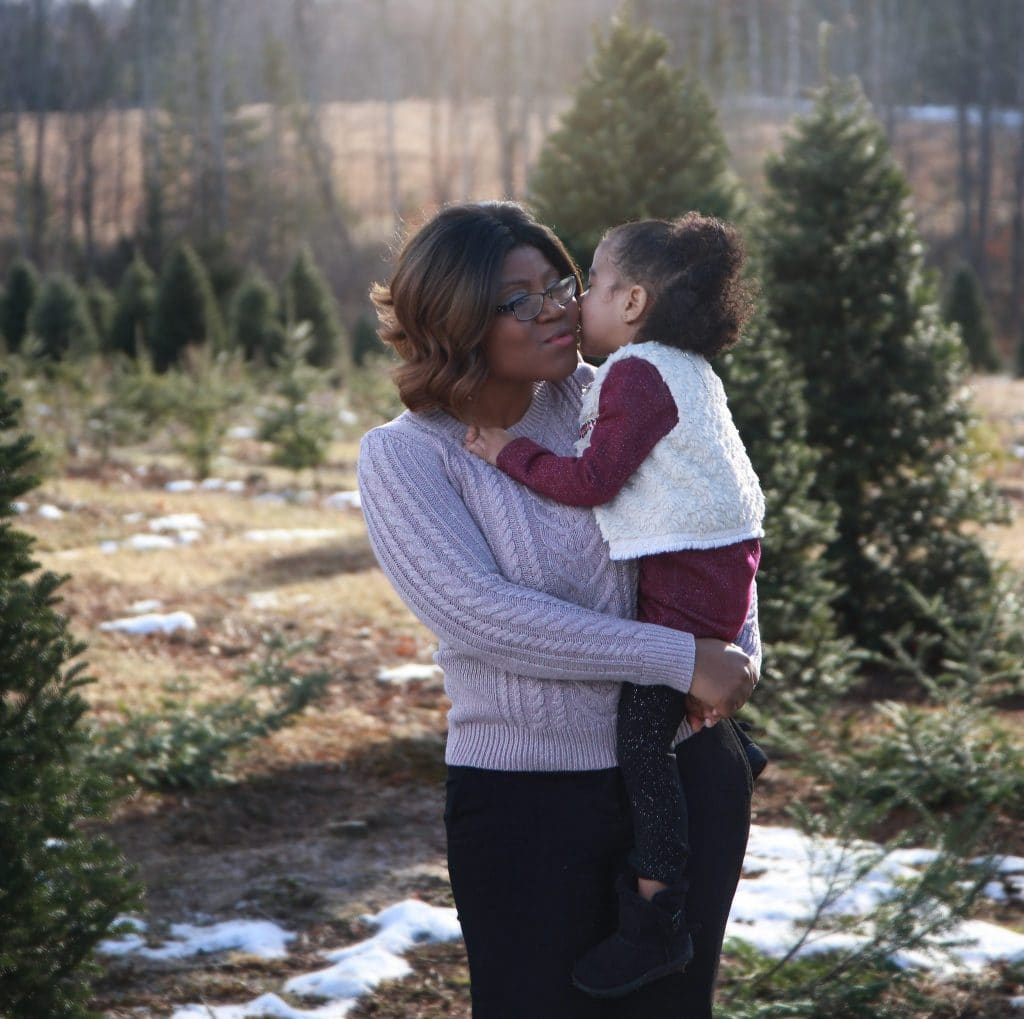What time of day and what might the weather be like based on the lighting and environment in the image? The image appears to be taken during late morning or early afternoon, as evidenced by the soft, diffused sunlight and its angle, which illuminates the subjects and the trees uniformly. The presence of some remaining snow patches and the visibly clear sky suggest it's a cold yet sunny day, typical of winter weather in many temperate regions. 